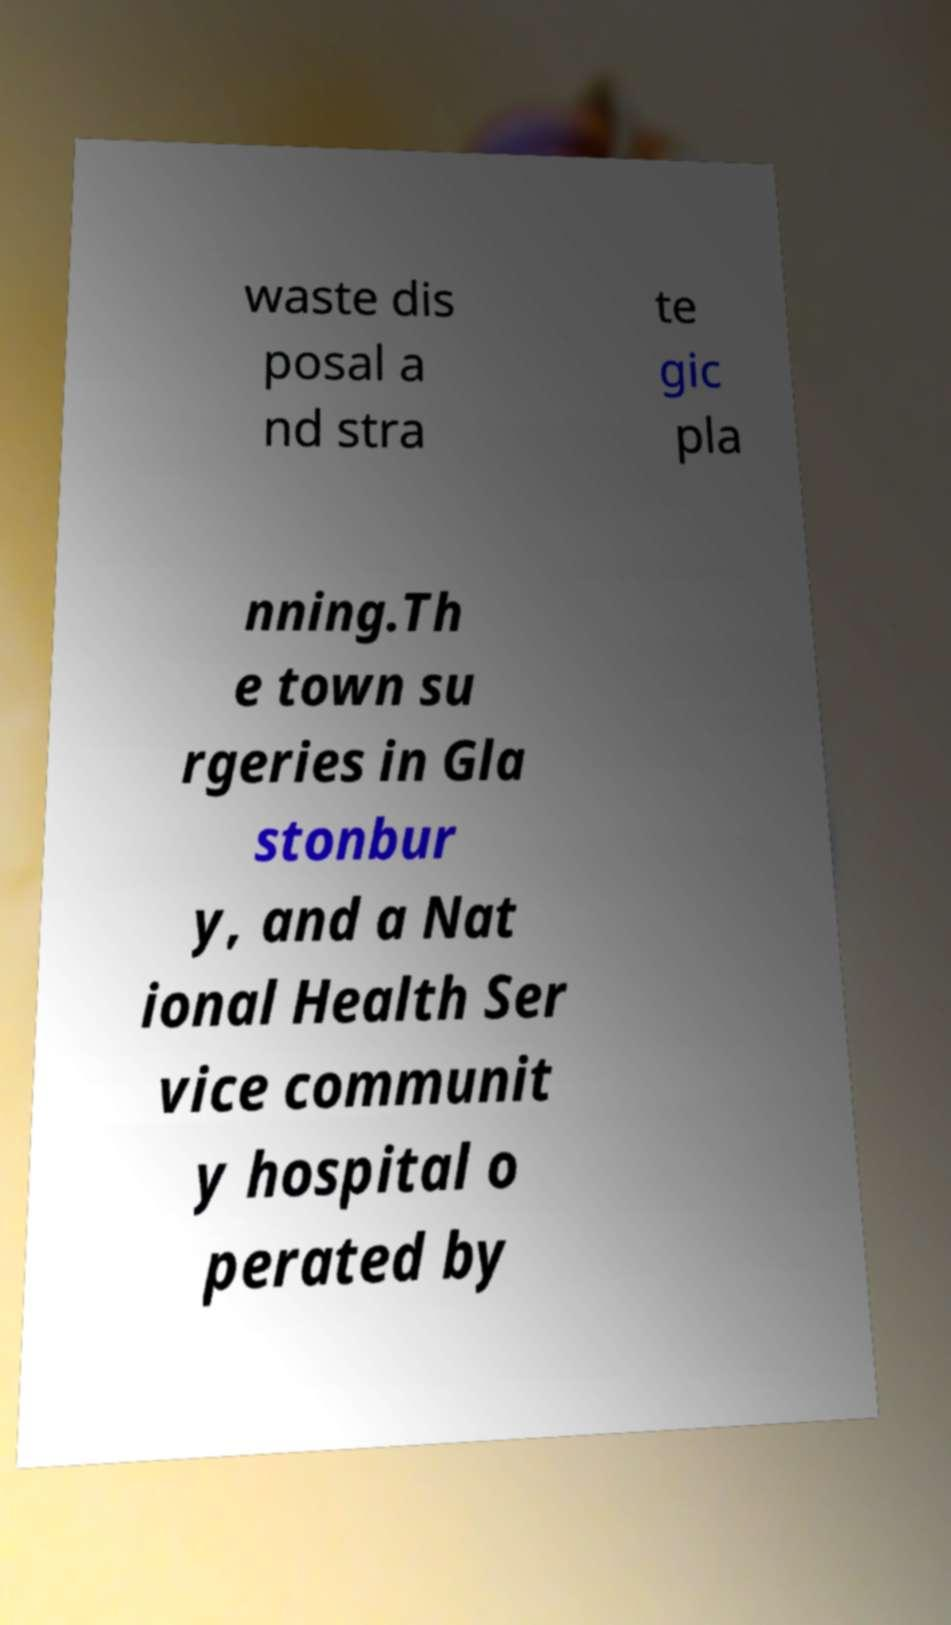Could you extract and type out the text from this image? waste dis posal a nd stra te gic pla nning.Th e town su rgeries in Gla stonbur y, and a Nat ional Health Ser vice communit y hospital o perated by 